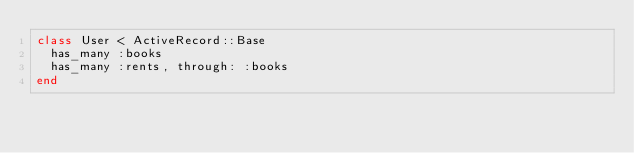<code> <loc_0><loc_0><loc_500><loc_500><_Ruby_>class User < ActiveRecord::Base
  has_many :books
  has_many :rents, through: :books
end
</code> 